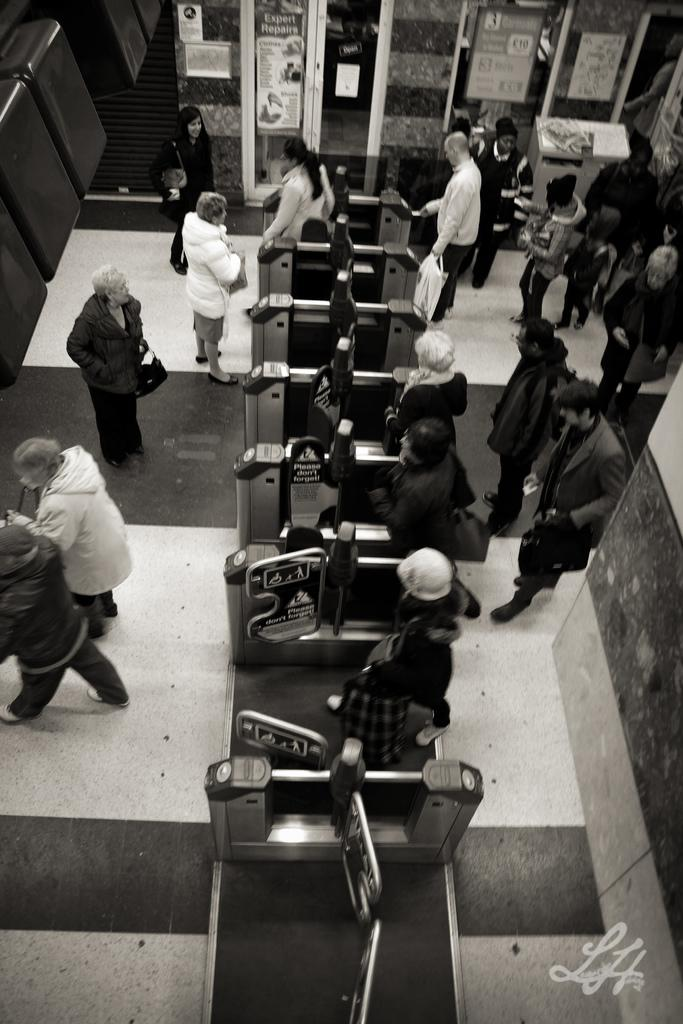What is the color scheme of the image? The image is black and white. What are the people in the image doing? People are walking in the image. Where is the entrance located in the image? There is an entrance in the middle of the image. What is the condition of the man's impulse in the image? There is no man or impulse present in the image, as it is a black and white image of people walking and an entrance. 